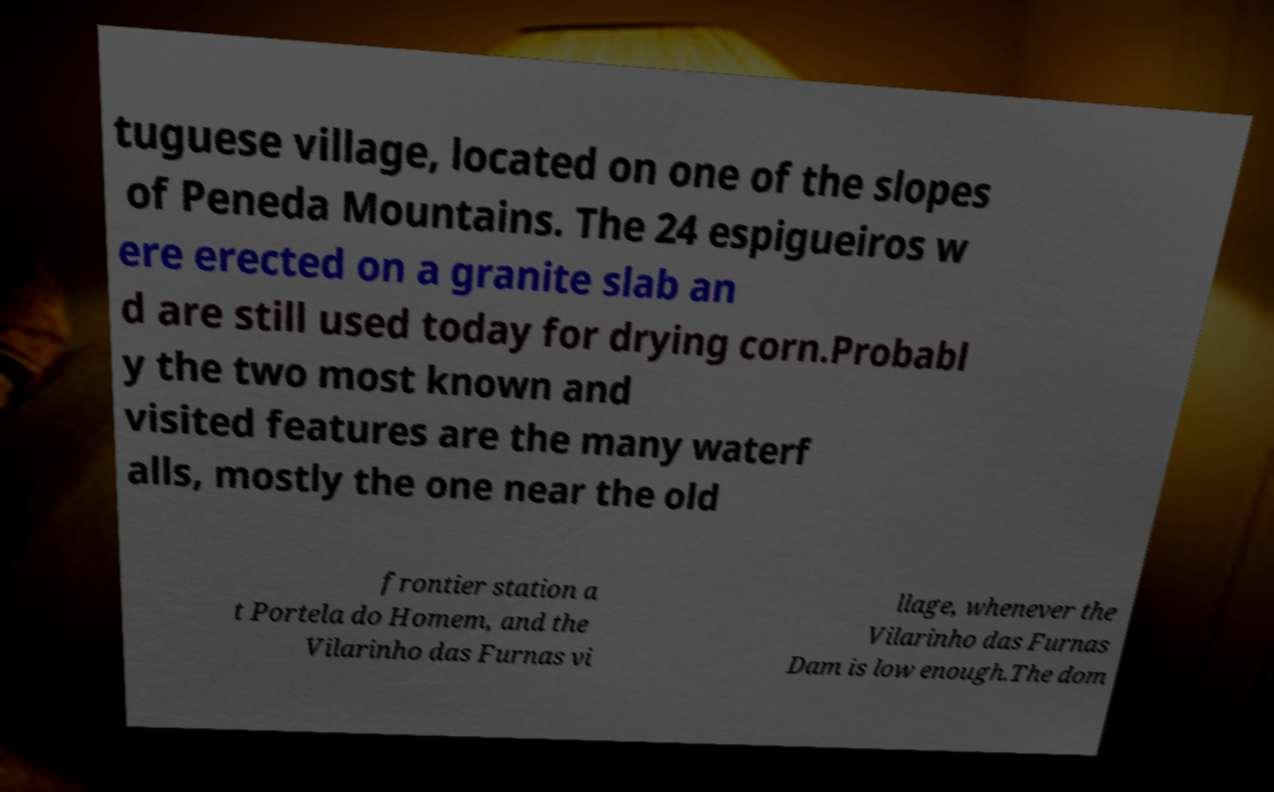Can you read and provide the text displayed in the image?This photo seems to have some interesting text. Can you extract and type it out for me? tuguese village, located on one of the slopes of Peneda Mountains. The 24 espigueiros w ere erected on a granite slab an d are still used today for drying corn.Probabl y the two most known and visited features are the many waterf alls, mostly the one near the old frontier station a t Portela do Homem, and the Vilarinho das Furnas vi llage, whenever the Vilarinho das Furnas Dam is low enough.The dom 